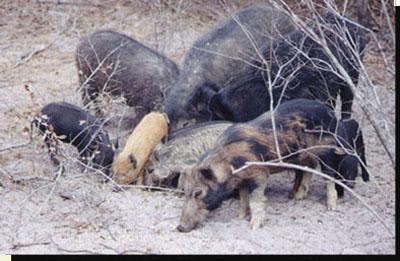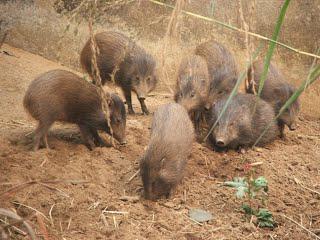The first image is the image on the left, the second image is the image on the right. For the images displayed, is the sentence "One image prominently features a single mature pig standing in profile, and the other image includes at least one piglet with distinctive stripes." factually correct? Answer yes or no. No. 